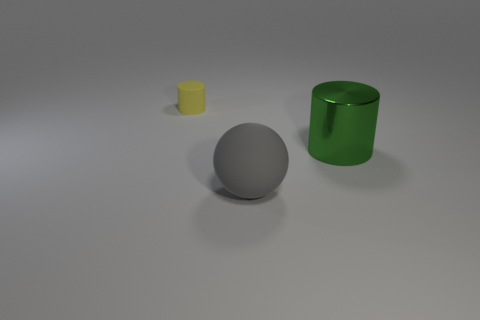Add 2 balls. How many objects exist? 5 Subtract all yellow cylinders. How many cylinders are left? 1 Subtract all balls. How many objects are left? 2 Subtract all purple cylinders. Subtract all brown cubes. How many cylinders are left? 2 Subtract all cyan cubes. How many yellow cylinders are left? 1 Subtract all matte objects. Subtract all large metallic cylinders. How many objects are left? 0 Add 1 green metal objects. How many green metal objects are left? 2 Add 1 tiny purple matte cylinders. How many tiny purple matte cylinders exist? 1 Subtract 0 purple cylinders. How many objects are left? 3 Subtract 1 spheres. How many spheres are left? 0 